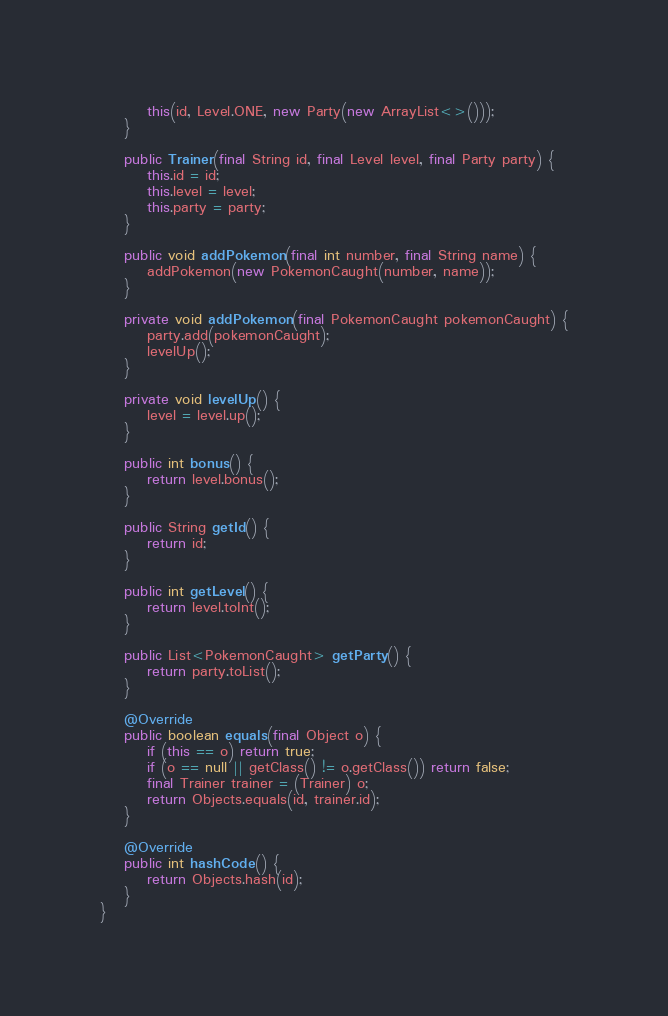Convert code to text. <code><loc_0><loc_0><loc_500><loc_500><_Java_>        this(id, Level.ONE, new Party(new ArrayList<>()));
    }

    public Trainer(final String id, final Level level, final Party party) {
        this.id = id;
        this.level = level;
        this.party = party;
    }

    public void addPokemon(final int number, final String name) {
        addPokemon(new PokemonCaught(number, name));
    }

    private void addPokemon(final PokemonCaught pokemonCaught) {
        party.add(pokemonCaught);
        levelUp();
    }

    private void levelUp() {
        level = level.up();
    }

    public int bonus() {
        return level.bonus();
    }

    public String getId() {
        return id;
    }

    public int getLevel() {
        return level.toInt();
    }

    public List<PokemonCaught> getParty() {
        return party.toList();
    }

    @Override
    public boolean equals(final Object o) {
        if (this == o) return true;
        if (o == null || getClass() != o.getClass()) return false;
        final Trainer trainer = (Trainer) o;
        return Objects.equals(id, trainer.id);
    }

    @Override
    public int hashCode() {
        return Objects.hash(id);
    }
}
</code> 